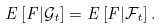Convert formula to latex. <formula><loc_0><loc_0><loc_500><loc_500>E \left [ F | \mathcal { G } _ { t } \right ] = E \left [ F | \mathcal { F } _ { t } \right ] .</formula> 